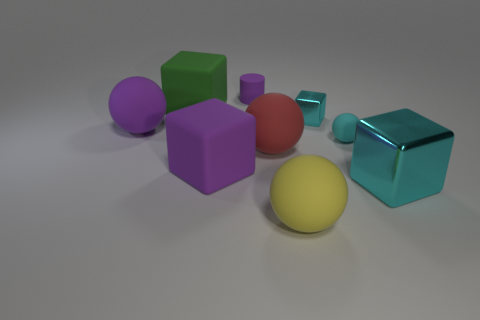Which shapes in the picture appear most frequently? Cubes and spheres appear to be the most prevalent shapes within the image. 